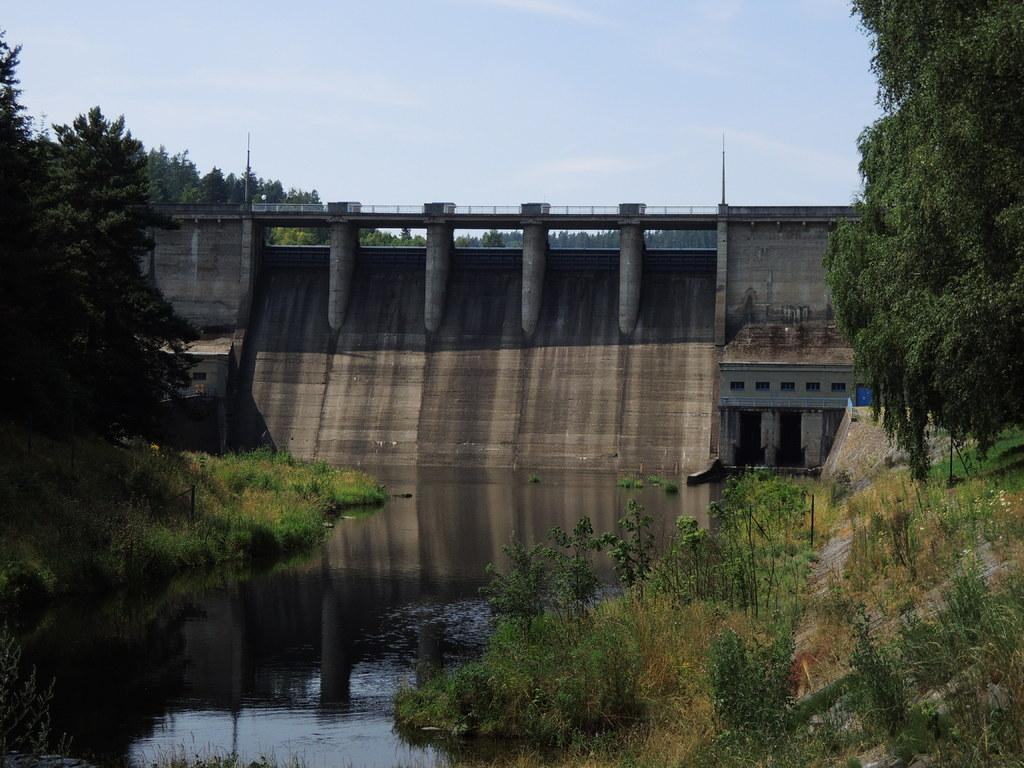What type of structure is present in the image? There is a dam in the image. What type of vegetation can be seen in the image? There are trees, grass, and plants visible in the image. What natural element is present in the image? There is water visible in the image. What part of the natural environment is visible in the image? The sky is visible in the image. What type of trade is being conducted in the image? There is no indication of trade in the image; it primarily features a dam and natural elements. 